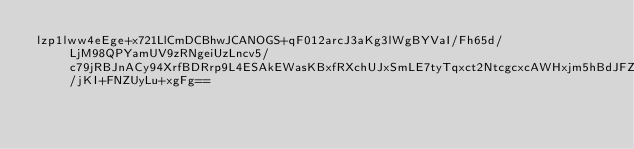Convert code to text. <code><loc_0><loc_0><loc_500><loc_500><_SML_>lzp1lww4eEge+x721LlCmDCBhwJCANOGS+qF012arcJ3aKg3lWgBYVaI/Fh65d/LjM98QPYamUV9zRNgeiUzLncv5/c79jRBJnACy94XrfBDRrp9L4ESAkEWasKBxfRXchUJxSmLE7tyTqxct2NtcgcxcAWHxjm5hBdJFZpBllYTsSSAz7ujyPdGDKvF3/jKI+FNZUyLu+xgFg==</code> 